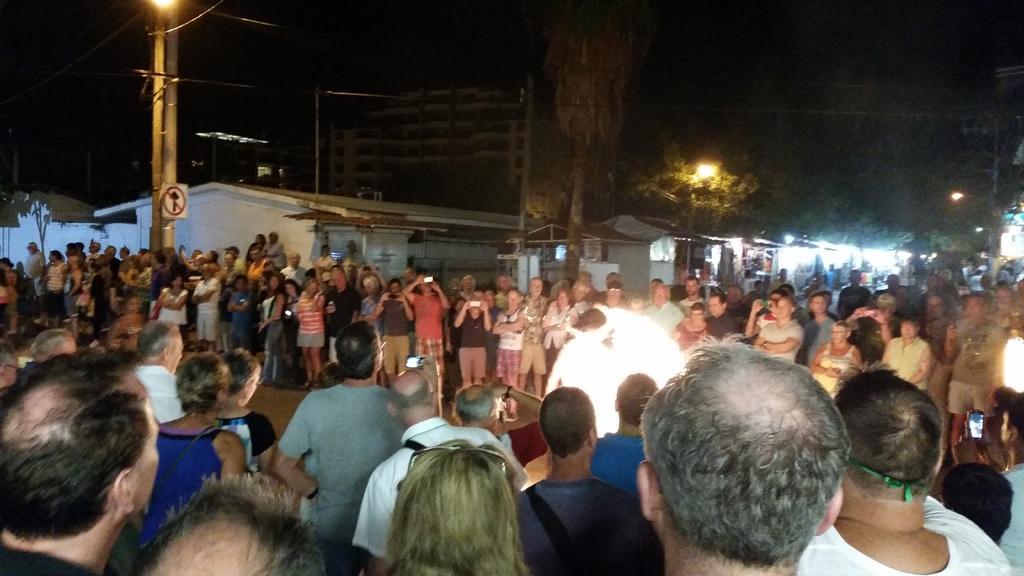Describe this image in one or two sentences. In the image we can see there is a lot of standing in a place and in between them there is a person standing in the middle. There are people holding cameras in their hand and behind there are lot of trees and there are buildings. 